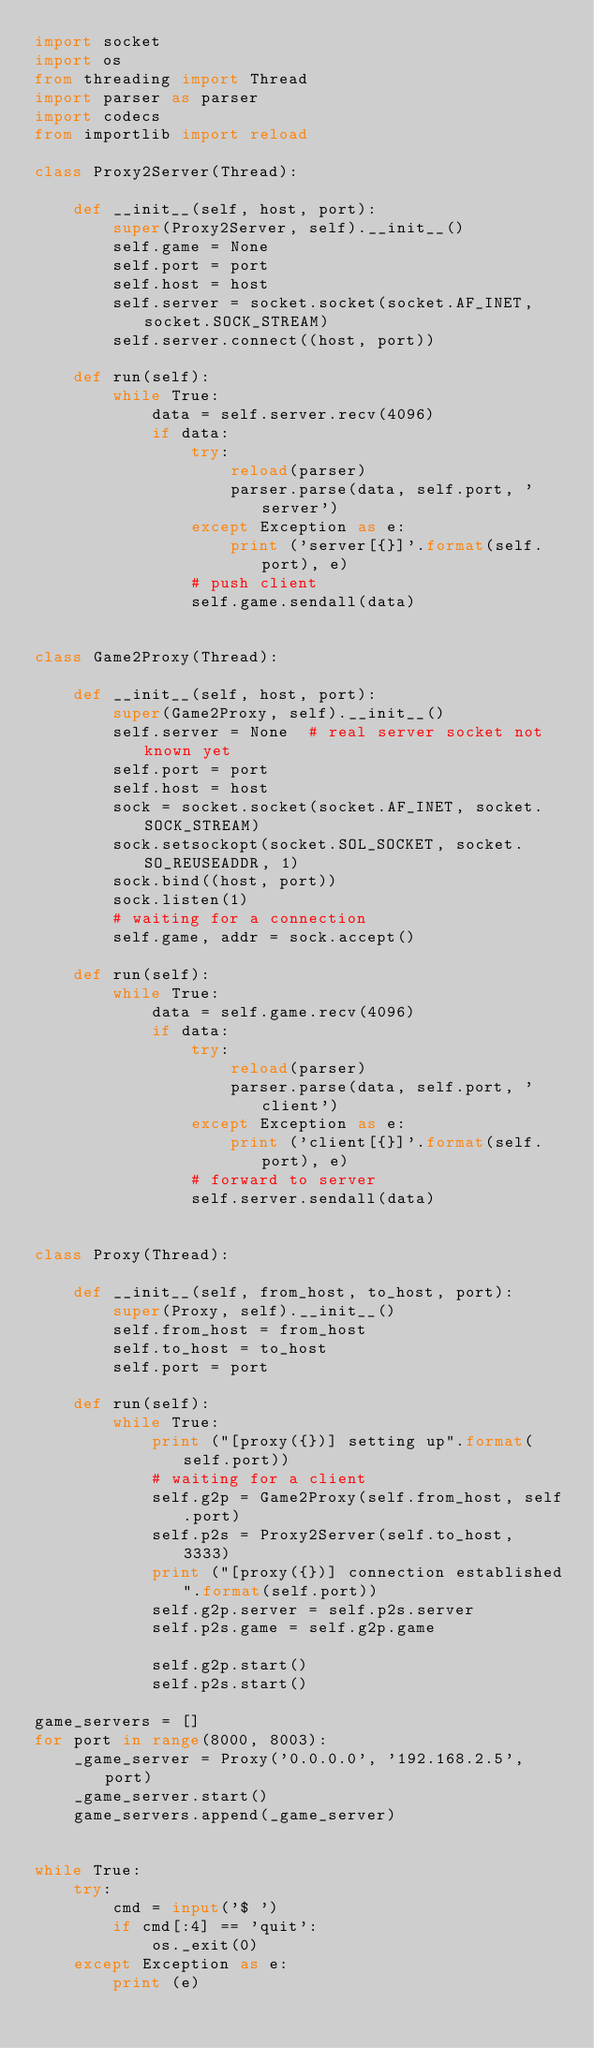Convert code to text. <code><loc_0><loc_0><loc_500><loc_500><_Python_>import socket
import os
from threading import Thread
import parser as parser
import codecs
from importlib import reload

class Proxy2Server(Thread):

    def __init__(self, host, port):
        super(Proxy2Server, self).__init__()
        self.game = None  
        self.port = port
        self.host = host
        self.server = socket.socket(socket.AF_INET, socket.SOCK_STREAM)
        self.server.connect((host, port))

    def run(self):
        while True:
            data = self.server.recv(4096)
            if data:
                try:
                    reload(parser)
                    parser.parse(data, self.port, 'server')
                except Exception as e:
                    print ('server[{}]'.format(self.port), e)
                # push client
                self.game.sendall(data)


class Game2Proxy(Thread):

    def __init__(self, host, port):
        super(Game2Proxy, self).__init__()
        self.server = None  # real server socket not known yet
        self.port = port
        self.host = host
        sock = socket.socket(socket.AF_INET, socket.SOCK_STREAM)
        sock.setsockopt(socket.SOL_SOCKET, socket.SO_REUSEADDR, 1)
        sock.bind((host, port))
        sock.listen(1)
        # waiting for a connection
        self.game, addr = sock.accept()

    def run(self):
        while True:
            data = self.game.recv(4096)
            if data:
                try:
                    reload(parser)
                    parser.parse(data, self.port, 'client')
                except Exception as e:
                    print ('client[{}]'.format(self.port), e)
                # forward to server
                self.server.sendall(data)


class Proxy(Thread):

    def __init__(self, from_host, to_host, port):
        super(Proxy, self).__init__()
        self.from_host = from_host
        self.to_host = to_host
        self.port = port

    def run(self):
        while True:
            print ("[proxy({})] setting up".format(self.port))
            # waiting for a client
            self.g2p = Game2Proxy(self.from_host, self.port)
            self.p2s = Proxy2Server(self.to_host, 3333)
            print ("[proxy({})] connection established".format(self.port))
            self.g2p.server = self.p2s.server
            self.p2s.game = self.g2p.game

            self.g2p.start()
            self.p2s.start()
            
game_servers = []
for port in range(8000, 8003):
    _game_server = Proxy('0.0.0.0', '192.168.2.5', port)
    _game_server.start()
    game_servers.append(_game_server)


while True:
    try:
        cmd = input('$ ')
        if cmd[:4] == 'quit':
            os._exit(0)
    except Exception as e:
        print (e)
</code> 